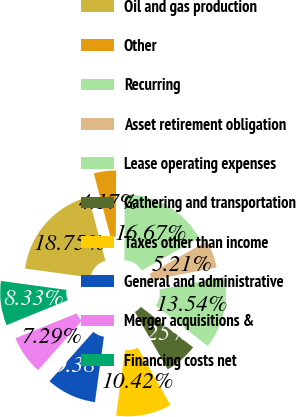<chart> <loc_0><loc_0><loc_500><loc_500><pie_chart><fcel>Oil and gas production<fcel>Other<fcel>Recurring<fcel>Asset retirement obligation<fcel>Lease operating expenses<fcel>Gathering and transportation<fcel>Taxes other than income<fcel>General and administrative<fcel>Merger acquisitions &<fcel>Financing costs net<nl><fcel>18.75%<fcel>4.17%<fcel>16.67%<fcel>5.21%<fcel>13.54%<fcel>6.25%<fcel>10.42%<fcel>9.38%<fcel>7.29%<fcel>8.33%<nl></chart> 